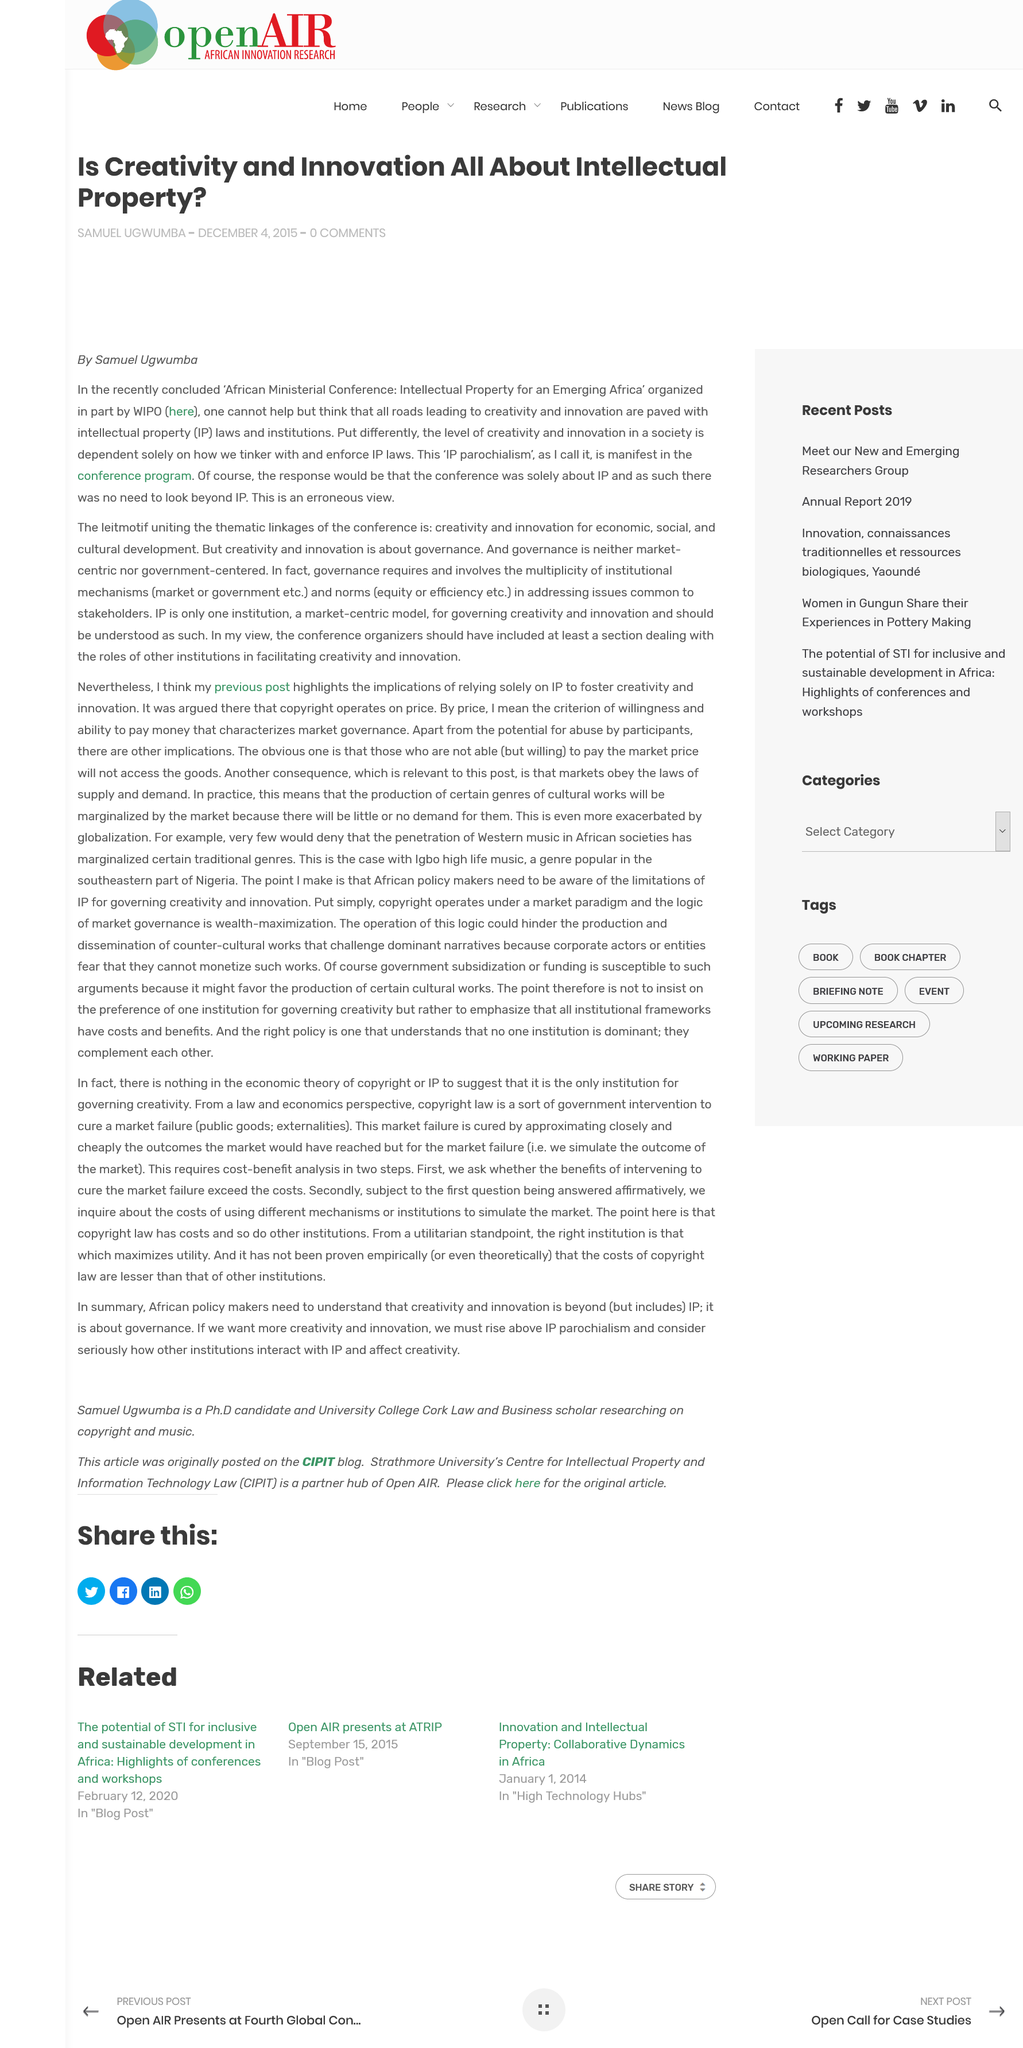Outline some significant characteristics in this image. The author of this article is Samuel Ugwumba. The article was written on December 4, 2015. The acronym IP refers to the term "Intellectual Property. 